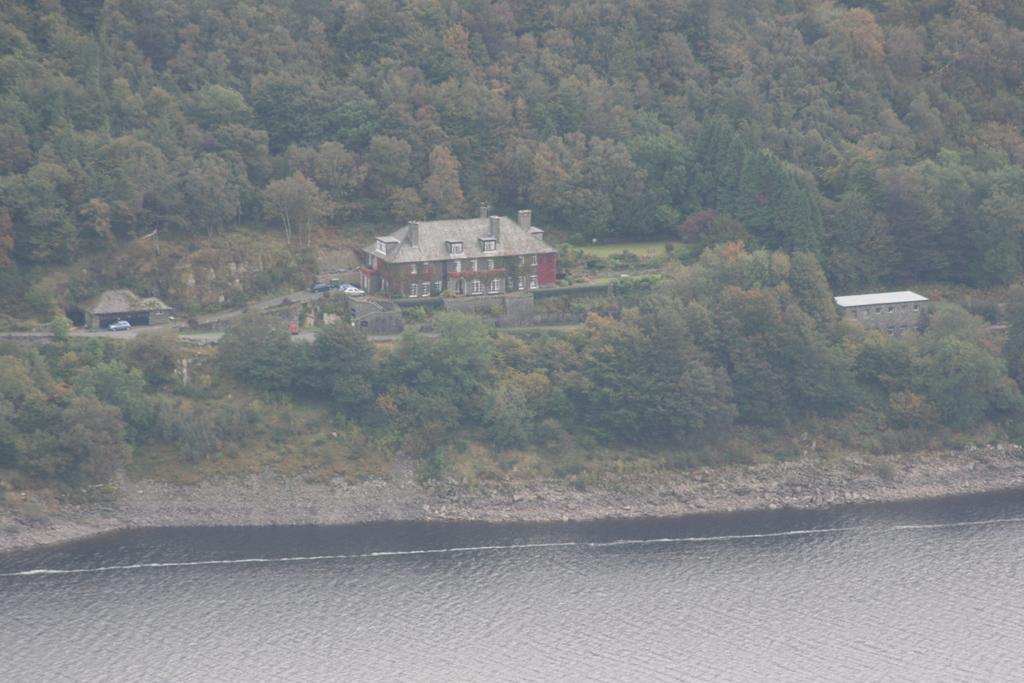Can you describe this image briefly? At the bottom of the image we can see water. In the middle of the image we can see some trees, buildings and vehicles. 